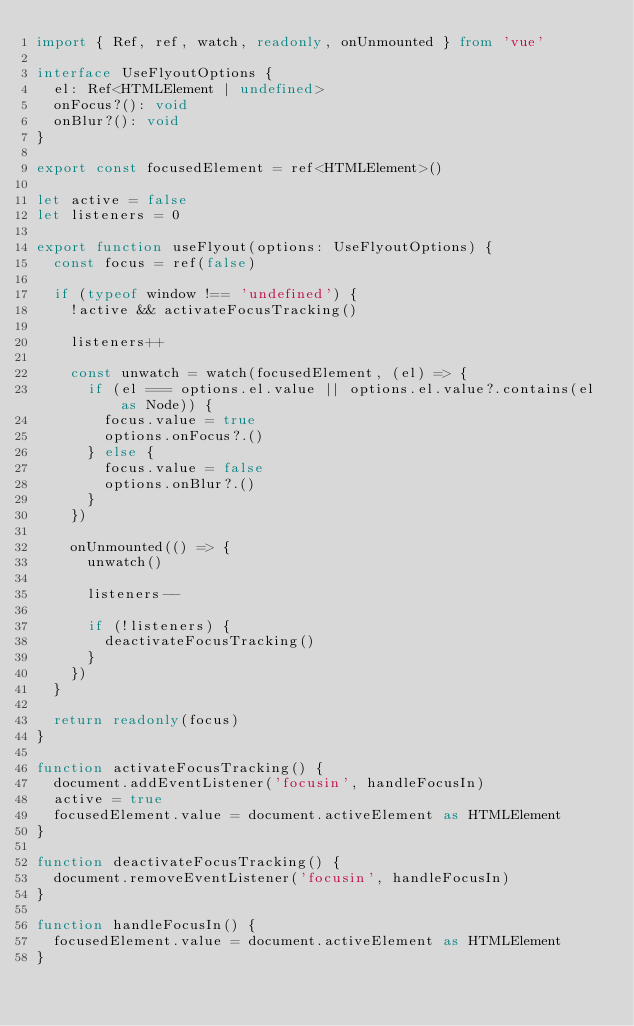Convert code to text. <code><loc_0><loc_0><loc_500><loc_500><_TypeScript_>import { Ref, ref, watch, readonly, onUnmounted } from 'vue'

interface UseFlyoutOptions {
  el: Ref<HTMLElement | undefined>
  onFocus?(): void
  onBlur?(): void
}

export const focusedElement = ref<HTMLElement>()

let active = false
let listeners = 0

export function useFlyout(options: UseFlyoutOptions) {
  const focus = ref(false)

  if (typeof window !== 'undefined') {
    !active && activateFocusTracking()

    listeners++

    const unwatch = watch(focusedElement, (el) => {
      if (el === options.el.value || options.el.value?.contains(el as Node)) {
        focus.value = true
        options.onFocus?.()
      } else {
        focus.value = false
        options.onBlur?.()
      }
    })

    onUnmounted(() => {
      unwatch()

      listeners--

      if (!listeners) {
        deactivateFocusTracking()
      }
    })
  }

  return readonly(focus)
}

function activateFocusTracking() {
  document.addEventListener('focusin', handleFocusIn)
  active = true
  focusedElement.value = document.activeElement as HTMLElement
}

function deactivateFocusTracking() {
  document.removeEventListener('focusin', handleFocusIn)
}

function handleFocusIn() {
  focusedElement.value = document.activeElement as HTMLElement
}
</code> 